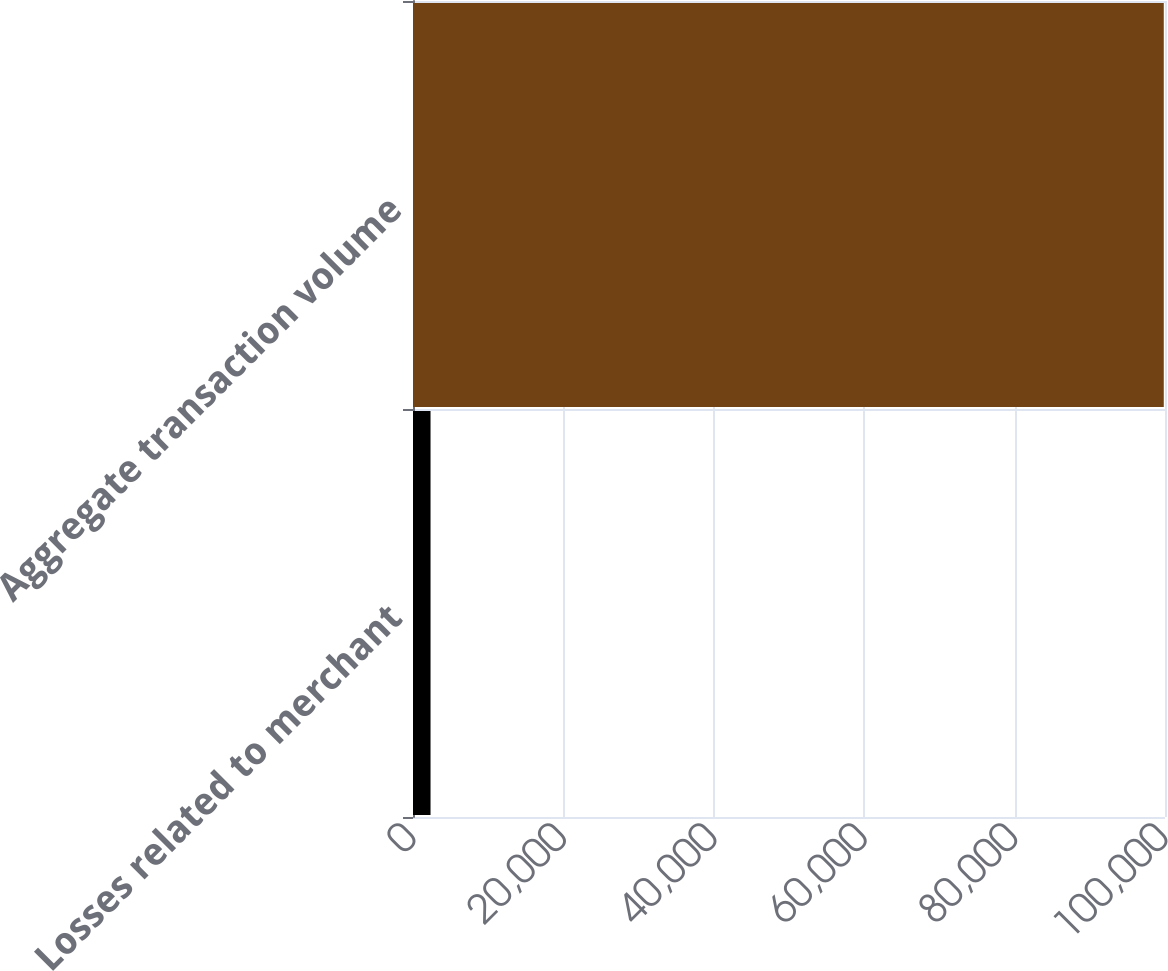Convert chart to OTSL. <chart><loc_0><loc_0><loc_500><loc_500><bar_chart><fcel>Losses related to merchant<fcel>Aggregate transaction volume<nl><fcel>2331<fcel>99838<nl></chart> 